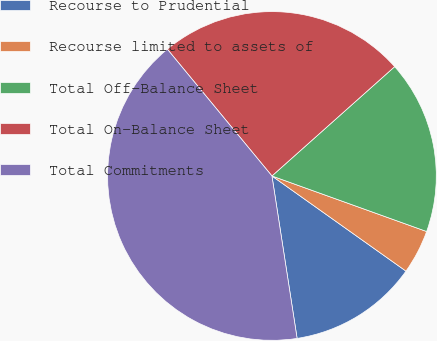<chart> <loc_0><loc_0><loc_500><loc_500><pie_chart><fcel>Recourse to Prudential<fcel>Recourse limited to assets of<fcel>Total Off-Balance Sheet<fcel>Total On-Balance Sheet<fcel>Total Commitments<nl><fcel>12.73%<fcel>4.34%<fcel>17.07%<fcel>24.4%<fcel>41.47%<nl></chart> 